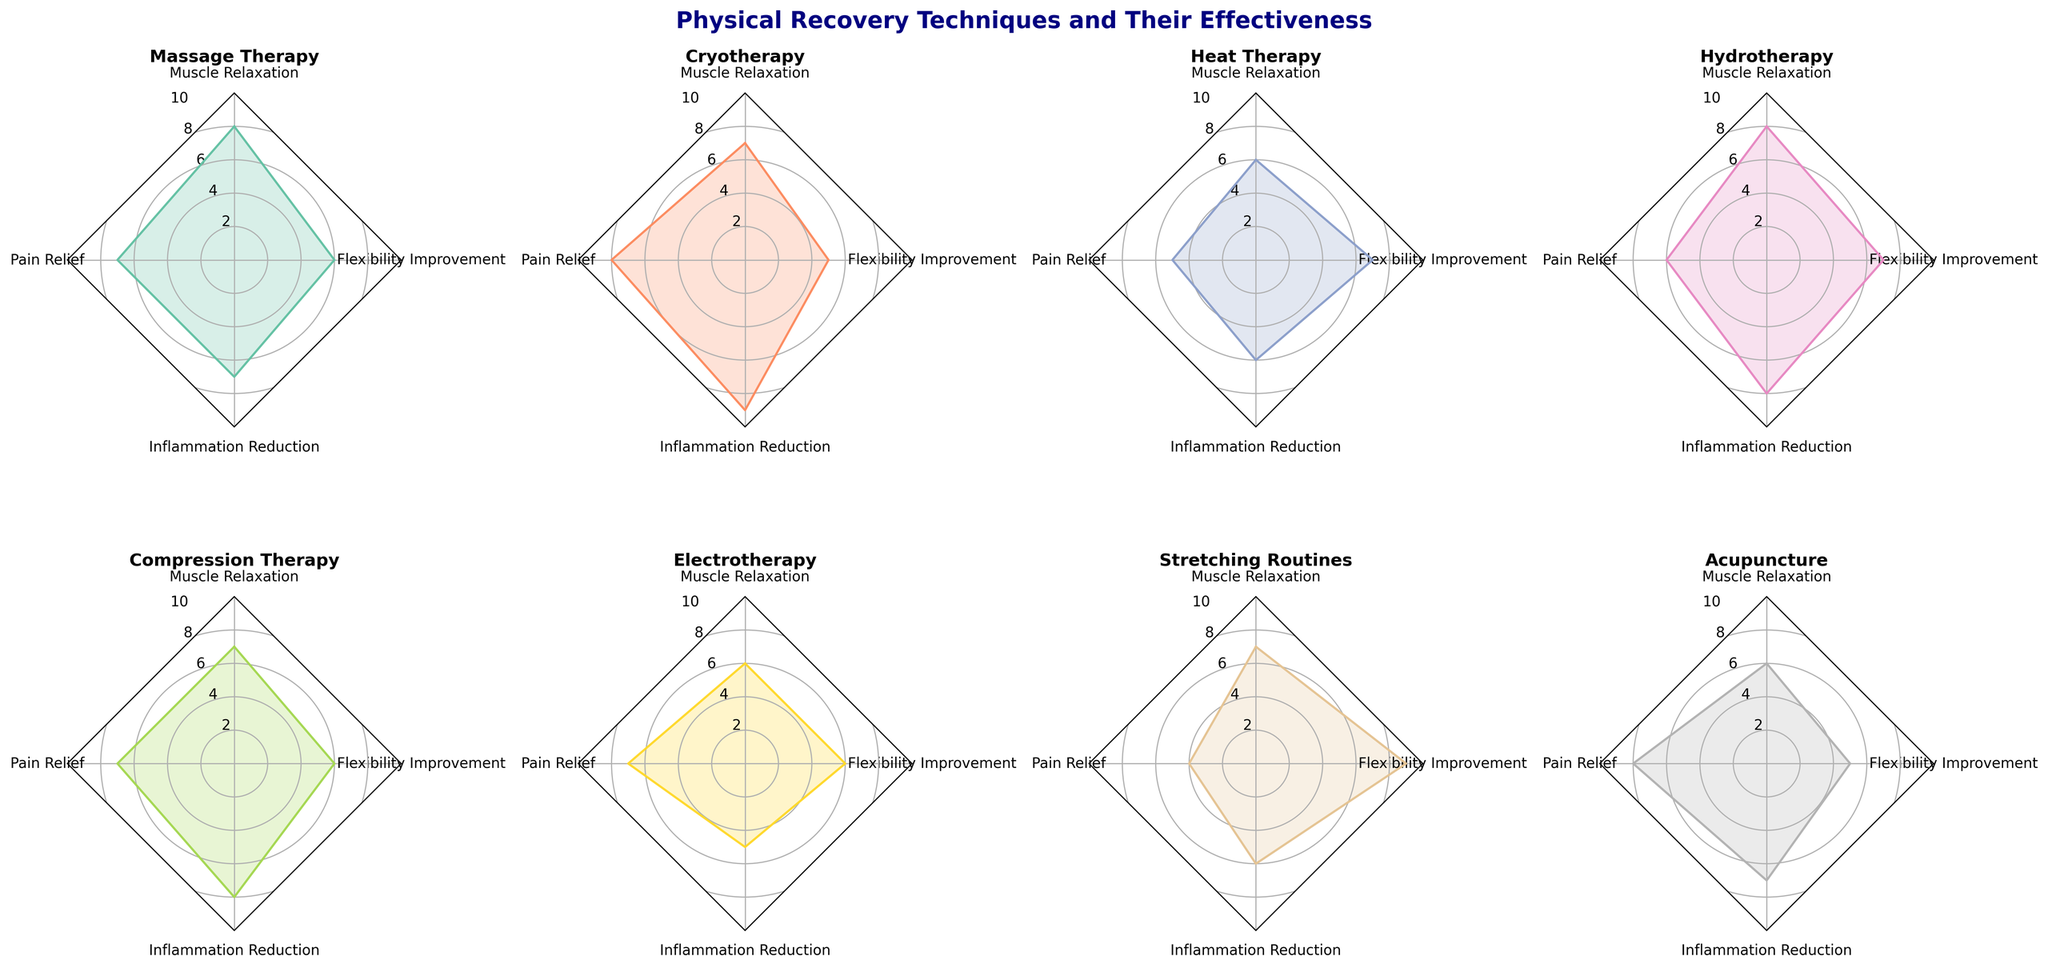What is the title of the figure? The title of the figure is typically placed at the top and is written in a larger, bold font. In this case, it is "Physical Recovery Techniques and Their Effectiveness".
Answer: Physical Recovery Techniques and Their Effectiveness Which recovery technique shows the highest muscle relaxation effectiveness? Each subplot represents a technique with axes corresponding to various effectiveness criteria. The Muscle Relaxation axis value is highest for Massage Therapy and Hydrotherapy, both having a value of 8.
Answer: Massage Therapy and Hydrotherapy Which technique has the lowest pain relief score? The Pain Relief axis should be examined for each subplot. Stretching Routines have the lowest score of 4 on this axis.
Answer: Stretching Routines What is the average inflammation reduction effectiveness across all techniques? The values for Inflammation Reduction should be summed up and divided by the number of techniques: (7+9+6+8+8+5+6+7)/8 = 7.
Answer: 7 Compare the flexibility improvement scores of Heat Therapy and Stretching Routines. The Flexibility Improvement axis shows that Heat Therapy has a score of 7, and Stretching Routines have a score of 9.
Answer: Stretching Routines is higher Which technique has the most balanced performance across all criteria? A balanced performance would mean similar scores across all axes, with no extreme highs or lows. Hydrotherapy seems to have relatively balanced scores without extreme peaks or lows across the axes.
Answer: Hydrotherapy What is the difference in inflammation reduction scores between Cryotherapy and Electrotherapy? Cryotherapy has 9 and Electrotherapy has 5, so the difference is 9 - 5 = 4.
Answer: 4 From the subplots, which technique provides the best pain relief? The Pain Relief axis reveals that Cryotherapy and Acupuncture have the highest score of 8.
Answer: Cryotherapy and Acupuncture How many techniques have a muscle relaxation score of 7 or higher? The Muscle Relaxation axis in each subplot should be examined. Massage Therapy (8), Cryotherapy (7), Hydrotherapy (8), Compression Therapy (7), and Stretching Routines (7) have scores of 7 or higher, thus 5 techniques.
Answer: 5 